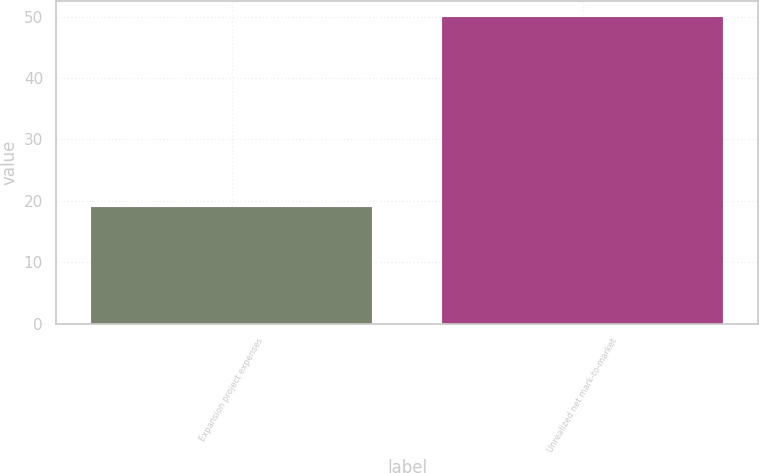<chart> <loc_0><loc_0><loc_500><loc_500><bar_chart><fcel>Expansion project expenses<fcel>Unrealized net mark-to-market<nl><fcel>19<fcel>50<nl></chart> 